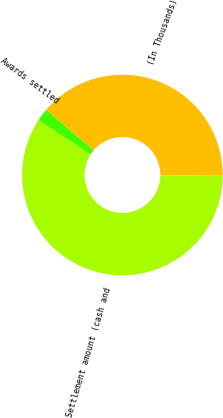<chart> <loc_0><loc_0><loc_500><loc_500><pie_chart><fcel>(In Thousands)<fcel>Awards settled<fcel>Settlement amount (cash and<nl><fcel>38.88%<fcel>2.09%<fcel>59.04%<nl></chart> 